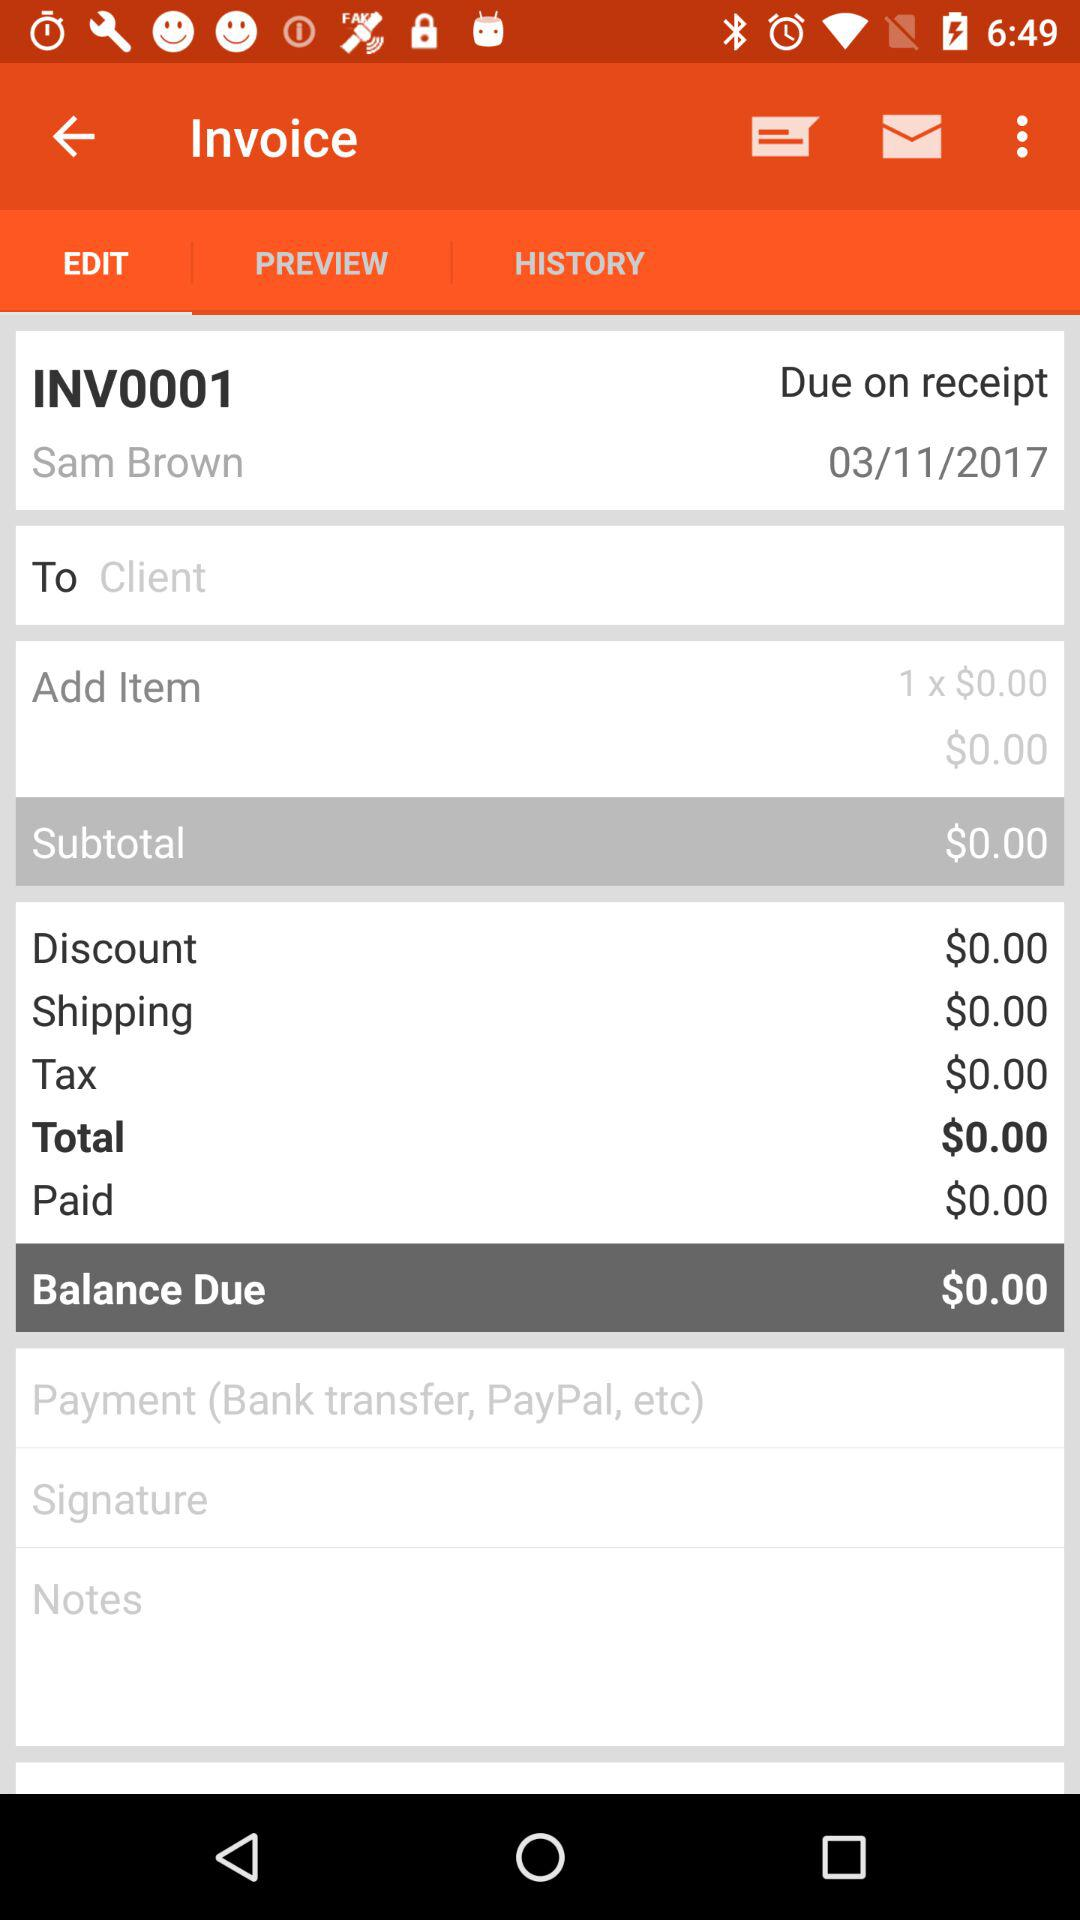What is the total amount of the invoice?
Answer the question using a single word or phrase. $0.00 